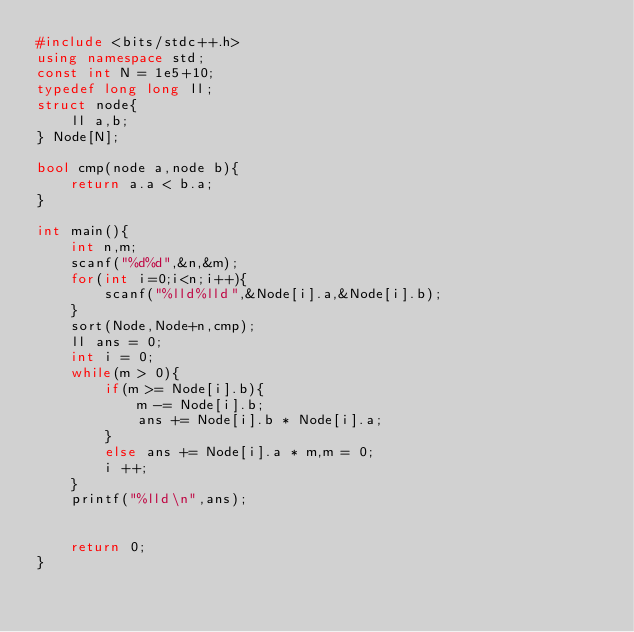<code> <loc_0><loc_0><loc_500><loc_500><_C++_>#include <bits/stdc++.h>
using namespace std;
const int N = 1e5+10;
typedef long long ll;
struct node{
    ll a,b;
} Node[N];

bool cmp(node a,node b){
    return a.a < b.a;
}

int main(){
    int n,m;
    scanf("%d%d",&n,&m);
    for(int i=0;i<n;i++){
        scanf("%lld%lld",&Node[i].a,&Node[i].b);
    }
    sort(Node,Node+n,cmp);
    ll ans = 0;
    int i = 0;
    while(m > 0){
        if(m >= Node[i].b){
            m -= Node[i].b;
            ans += Node[i].b * Node[i].a;
        }
        else ans += Node[i].a * m,m = 0;
        i ++;
    }
    printf("%lld\n",ans);


    return 0;
}
</code> 